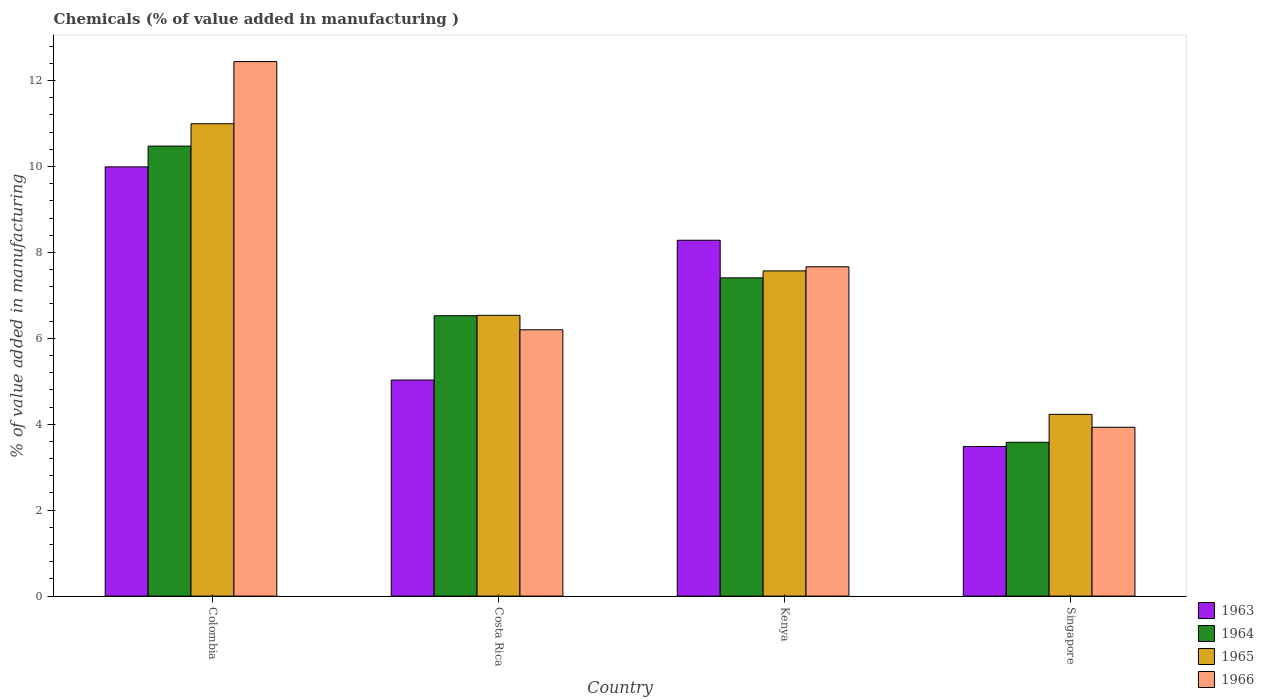How many different coloured bars are there?
Your response must be concise. 4. Are the number of bars on each tick of the X-axis equal?
Your response must be concise. Yes. What is the label of the 4th group of bars from the left?
Make the answer very short. Singapore. What is the value added in manufacturing chemicals in 1964 in Costa Rica?
Provide a succinct answer. 6.53. Across all countries, what is the maximum value added in manufacturing chemicals in 1964?
Offer a terse response. 10.47. Across all countries, what is the minimum value added in manufacturing chemicals in 1964?
Make the answer very short. 3.58. In which country was the value added in manufacturing chemicals in 1964 minimum?
Keep it short and to the point. Singapore. What is the total value added in manufacturing chemicals in 1963 in the graph?
Your response must be concise. 26.79. What is the difference between the value added in manufacturing chemicals in 1964 in Costa Rica and that in Singapore?
Make the answer very short. 2.95. What is the difference between the value added in manufacturing chemicals in 1966 in Kenya and the value added in manufacturing chemicals in 1965 in Colombia?
Give a very brief answer. -3.33. What is the average value added in manufacturing chemicals in 1963 per country?
Your answer should be compact. 6.7. What is the difference between the value added in manufacturing chemicals of/in 1963 and value added in manufacturing chemicals of/in 1964 in Singapore?
Make the answer very short. -0.1. In how many countries, is the value added in manufacturing chemicals in 1963 greater than 2.8 %?
Your response must be concise. 4. What is the ratio of the value added in manufacturing chemicals in 1963 in Colombia to that in Kenya?
Your answer should be compact. 1.21. What is the difference between the highest and the second highest value added in manufacturing chemicals in 1964?
Provide a short and direct response. 3.95. What is the difference between the highest and the lowest value added in manufacturing chemicals in 1963?
Ensure brevity in your answer.  6.51. In how many countries, is the value added in manufacturing chemicals in 1963 greater than the average value added in manufacturing chemicals in 1963 taken over all countries?
Provide a succinct answer. 2. Is the sum of the value added in manufacturing chemicals in 1965 in Kenya and Singapore greater than the maximum value added in manufacturing chemicals in 1966 across all countries?
Make the answer very short. No. What does the 2nd bar from the left in Kenya represents?
Your answer should be very brief. 1964. What does the 2nd bar from the right in Kenya represents?
Provide a short and direct response. 1965. Is it the case that in every country, the sum of the value added in manufacturing chemicals in 1964 and value added in manufacturing chemicals in 1966 is greater than the value added in manufacturing chemicals in 1963?
Your answer should be compact. Yes. Are all the bars in the graph horizontal?
Make the answer very short. No. How many countries are there in the graph?
Offer a terse response. 4. What is the difference between two consecutive major ticks on the Y-axis?
Provide a short and direct response. 2. Does the graph contain any zero values?
Provide a succinct answer. No. Where does the legend appear in the graph?
Give a very brief answer. Bottom right. How many legend labels are there?
Provide a short and direct response. 4. How are the legend labels stacked?
Provide a short and direct response. Vertical. What is the title of the graph?
Provide a succinct answer. Chemicals (% of value added in manufacturing ). What is the label or title of the X-axis?
Keep it short and to the point. Country. What is the label or title of the Y-axis?
Provide a short and direct response. % of value added in manufacturing. What is the % of value added in manufacturing of 1963 in Colombia?
Offer a terse response. 9.99. What is the % of value added in manufacturing of 1964 in Colombia?
Your answer should be very brief. 10.47. What is the % of value added in manufacturing of 1965 in Colombia?
Make the answer very short. 10.99. What is the % of value added in manufacturing of 1966 in Colombia?
Your answer should be very brief. 12.44. What is the % of value added in manufacturing in 1963 in Costa Rica?
Your response must be concise. 5.03. What is the % of value added in manufacturing in 1964 in Costa Rica?
Keep it short and to the point. 6.53. What is the % of value added in manufacturing of 1965 in Costa Rica?
Make the answer very short. 6.54. What is the % of value added in manufacturing in 1966 in Costa Rica?
Make the answer very short. 6.2. What is the % of value added in manufacturing of 1963 in Kenya?
Offer a very short reply. 8.28. What is the % of value added in manufacturing of 1964 in Kenya?
Give a very brief answer. 7.41. What is the % of value added in manufacturing in 1965 in Kenya?
Your answer should be very brief. 7.57. What is the % of value added in manufacturing in 1966 in Kenya?
Ensure brevity in your answer.  7.67. What is the % of value added in manufacturing in 1963 in Singapore?
Your answer should be compact. 3.48. What is the % of value added in manufacturing of 1964 in Singapore?
Provide a succinct answer. 3.58. What is the % of value added in manufacturing of 1965 in Singapore?
Offer a very short reply. 4.23. What is the % of value added in manufacturing in 1966 in Singapore?
Provide a succinct answer. 3.93. Across all countries, what is the maximum % of value added in manufacturing of 1963?
Give a very brief answer. 9.99. Across all countries, what is the maximum % of value added in manufacturing in 1964?
Give a very brief answer. 10.47. Across all countries, what is the maximum % of value added in manufacturing of 1965?
Your answer should be compact. 10.99. Across all countries, what is the maximum % of value added in manufacturing in 1966?
Ensure brevity in your answer.  12.44. Across all countries, what is the minimum % of value added in manufacturing of 1963?
Give a very brief answer. 3.48. Across all countries, what is the minimum % of value added in manufacturing of 1964?
Make the answer very short. 3.58. Across all countries, what is the minimum % of value added in manufacturing in 1965?
Ensure brevity in your answer.  4.23. Across all countries, what is the minimum % of value added in manufacturing of 1966?
Keep it short and to the point. 3.93. What is the total % of value added in manufacturing of 1963 in the graph?
Your response must be concise. 26.79. What is the total % of value added in manufacturing in 1964 in the graph?
Offer a very short reply. 27.99. What is the total % of value added in manufacturing of 1965 in the graph?
Provide a short and direct response. 29.33. What is the total % of value added in manufacturing of 1966 in the graph?
Your response must be concise. 30.23. What is the difference between the % of value added in manufacturing in 1963 in Colombia and that in Costa Rica?
Give a very brief answer. 4.96. What is the difference between the % of value added in manufacturing in 1964 in Colombia and that in Costa Rica?
Offer a terse response. 3.95. What is the difference between the % of value added in manufacturing of 1965 in Colombia and that in Costa Rica?
Provide a succinct answer. 4.46. What is the difference between the % of value added in manufacturing of 1966 in Colombia and that in Costa Rica?
Your answer should be very brief. 6.24. What is the difference between the % of value added in manufacturing of 1963 in Colombia and that in Kenya?
Give a very brief answer. 1.71. What is the difference between the % of value added in manufacturing of 1964 in Colombia and that in Kenya?
Your response must be concise. 3.07. What is the difference between the % of value added in manufacturing of 1965 in Colombia and that in Kenya?
Your response must be concise. 3.43. What is the difference between the % of value added in manufacturing of 1966 in Colombia and that in Kenya?
Your answer should be compact. 4.78. What is the difference between the % of value added in manufacturing in 1963 in Colombia and that in Singapore?
Your answer should be compact. 6.51. What is the difference between the % of value added in manufacturing in 1964 in Colombia and that in Singapore?
Your response must be concise. 6.89. What is the difference between the % of value added in manufacturing of 1965 in Colombia and that in Singapore?
Your answer should be very brief. 6.76. What is the difference between the % of value added in manufacturing of 1966 in Colombia and that in Singapore?
Ensure brevity in your answer.  8.51. What is the difference between the % of value added in manufacturing of 1963 in Costa Rica and that in Kenya?
Ensure brevity in your answer.  -3.25. What is the difference between the % of value added in manufacturing of 1964 in Costa Rica and that in Kenya?
Keep it short and to the point. -0.88. What is the difference between the % of value added in manufacturing in 1965 in Costa Rica and that in Kenya?
Your answer should be very brief. -1.03. What is the difference between the % of value added in manufacturing of 1966 in Costa Rica and that in Kenya?
Ensure brevity in your answer.  -1.47. What is the difference between the % of value added in manufacturing of 1963 in Costa Rica and that in Singapore?
Your response must be concise. 1.55. What is the difference between the % of value added in manufacturing of 1964 in Costa Rica and that in Singapore?
Your response must be concise. 2.95. What is the difference between the % of value added in manufacturing of 1965 in Costa Rica and that in Singapore?
Provide a succinct answer. 2.31. What is the difference between the % of value added in manufacturing of 1966 in Costa Rica and that in Singapore?
Your answer should be compact. 2.27. What is the difference between the % of value added in manufacturing in 1963 in Kenya and that in Singapore?
Offer a terse response. 4.8. What is the difference between the % of value added in manufacturing in 1964 in Kenya and that in Singapore?
Offer a very short reply. 3.83. What is the difference between the % of value added in manufacturing of 1965 in Kenya and that in Singapore?
Make the answer very short. 3.34. What is the difference between the % of value added in manufacturing in 1966 in Kenya and that in Singapore?
Provide a succinct answer. 3.74. What is the difference between the % of value added in manufacturing in 1963 in Colombia and the % of value added in manufacturing in 1964 in Costa Rica?
Your response must be concise. 3.47. What is the difference between the % of value added in manufacturing in 1963 in Colombia and the % of value added in manufacturing in 1965 in Costa Rica?
Offer a very short reply. 3.46. What is the difference between the % of value added in manufacturing of 1963 in Colombia and the % of value added in manufacturing of 1966 in Costa Rica?
Offer a very short reply. 3.79. What is the difference between the % of value added in manufacturing in 1964 in Colombia and the % of value added in manufacturing in 1965 in Costa Rica?
Provide a short and direct response. 3.94. What is the difference between the % of value added in manufacturing in 1964 in Colombia and the % of value added in manufacturing in 1966 in Costa Rica?
Ensure brevity in your answer.  4.28. What is the difference between the % of value added in manufacturing of 1965 in Colombia and the % of value added in manufacturing of 1966 in Costa Rica?
Provide a short and direct response. 4.8. What is the difference between the % of value added in manufacturing in 1963 in Colombia and the % of value added in manufacturing in 1964 in Kenya?
Keep it short and to the point. 2.58. What is the difference between the % of value added in manufacturing of 1963 in Colombia and the % of value added in manufacturing of 1965 in Kenya?
Your answer should be compact. 2.42. What is the difference between the % of value added in manufacturing of 1963 in Colombia and the % of value added in manufacturing of 1966 in Kenya?
Ensure brevity in your answer.  2.33. What is the difference between the % of value added in manufacturing of 1964 in Colombia and the % of value added in manufacturing of 1965 in Kenya?
Ensure brevity in your answer.  2.9. What is the difference between the % of value added in manufacturing in 1964 in Colombia and the % of value added in manufacturing in 1966 in Kenya?
Provide a succinct answer. 2.81. What is the difference between the % of value added in manufacturing of 1965 in Colombia and the % of value added in manufacturing of 1966 in Kenya?
Give a very brief answer. 3.33. What is the difference between the % of value added in manufacturing in 1963 in Colombia and the % of value added in manufacturing in 1964 in Singapore?
Provide a short and direct response. 6.41. What is the difference between the % of value added in manufacturing of 1963 in Colombia and the % of value added in manufacturing of 1965 in Singapore?
Offer a terse response. 5.76. What is the difference between the % of value added in manufacturing in 1963 in Colombia and the % of value added in manufacturing in 1966 in Singapore?
Your answer should be compact. 6.06. What is the difference between the % of value added in manufacturing of 1964 in Colombia and the % of value added in manufacturing of 1965 in Singapore?
Keep it short and to the point. 6.24. What is the difference between the % of value added in manufacturing in 1964 in Colombia and the % of value added in manufacturing in 1966 in Singapore?
Make the answer very short. 6.54. What is the difference between the % of value added in manufacturing of 1965 in Colombia and the % of value added in manufacturing of 1966 in Singapore?
Keep it short and to the point. 7.07. What is the difference between the % of value added in manufacturing in 1963 in Costa Rica and the % of value added in manufacturing in 1964 in Kenya?
Give a very brief answer. -2.38. What is the difference between the % of value added in manufacturing in 1963 in Costa Rica and the % of value added in manufacturing in 1965 in Kenya?
Ensure brevity in your answer.  -2.54. What is the difference between the % of value added in manufacturing of 1963 in Costa Rica and the % of value added in manufacturing of 1966 in Kenya?
Make the answer very short. -2.64. What is the difference between the % of value added in manufacturing of 1964 in Costa Rica and the % of value added in manufacturing of 1965 in Kenya?
Offer a terse response. -1.04. What is the difference between the % of value added in manufacturing in 1964 in Costa Rica and the % of value added in manufacturing in 1966 in Kenya?
Offer a terse response. -1.14. What is the difference between the % of value added in manufacturing of 1965 in Costa Rica and the % of value added in manufacturing of 1966 in Kenya?
Provide a short and direct response. -1.13. What is the difference between the % of value added in manufacturing of 1963 in Costa Rica and the % of value added in manufacturing of 1964 in Singapore?
Give a very brief answer. 1.45. What is the difference between the % of value added in manufacturing in 1963 in Costa Rica and the % of value added in manufacturing in 1965 in Singapore?
Ensure brevity in your answer.  0.8. What is the difference between the % of value added in manufacturing of 1963 in Costa Rica and the % of value added in manufacturing of 1966 in Singapore?
Offer a terse response. 1.1. What is the difference between the % of value added in manufacturing of 1964 in Costa Rica and the % of value added in manufacturing of 1965 in Singapore?
Keep it short and to the point. 2.3. What is the difference between the % of value added in manufacturing of 1964 in Costa Rica and the % of value added in manufacturing of 1966 in Singapore?
Your answer should be compact. 2.6. What is the difference between the % of value added in manufacturing of 1965 in Costa Rica and the % of value added in manufacturing of 1966 in Singapore?
Provide a short and direct response. 2.61. What is the difference between the % of value added in manufacturing of 1963 in Kenya and the % of value added in manufacturing of 1964 in Singapore?
Your answer should be compact. 4.7. What is the difference between the % of value added in manufacturing in 1963 in Kenya and the % of value added in manufacturing in 1965 in Singapore?
Ensure brevity in your answer.  4.05. What is the difference between the % of value added in manufacturing in 1963 in Kenya and the % of value added in manufacturing in 1966 in Singapore?
Your response must be concise. 4.35. What is the difference between the % of value added in manufacturing in 1964 in Kenya and the % of value added in manufacturing in 1965 in Singapore?
Offer a very short reply. 3.18. What is the difference between the % of value added in manufacturing of 1964 in Kenya and the % of value added in manufacturing of 1966 in Singapore?
Your answer should be compact. 3.48. What is the difference between the % of value added in manufacturing of 1965 in Kenya and the % of value added in manufacturing of 1966 in Singapore?
Your response must be concise. 3.64. What is the average % of value added in manufacturing of 1963 per country?
Make the answer very short. 6.7. What is the average % of value added in manufacturing of 1964 per country?
Your answer should be very brief. 7. What is the average % of value added in manufacturing in 1965 per country?
Offer a very short reply. 7.33. What is the average % of value added in manufacturing of 1966 per country?
Your response must be concise. 7.56. What is the difference between the % of value added in manufacturing of 1963 and % of value added in manufacturing of 1964 in Colombia?
Offer a terse response. -0.48. What is the difference between the % of value added in manufacturing of 1963 and % of value added in manufacturing of 1965 in Colombia?
Offer a terse response. -1. What is the difference between the % of value added in manufacturing in 1963 and % of value added in manufacturing in 1966 in Colombia?
Ensure brevity in your answer.  -2.45. What is the difference between the % of value added in manufacturing in 1964 and % of value added in manufacturing in 1965 in Colombia?
Give a very brief answer. -0.52. What is the difference between the % of value added in manufacturing in 1964 and % of value added in manufacturing in 1966 in Colombia?
Keep it short and to the point. -1.97. What is the difference between the % of value added in manufacturing in 1965 and % of value added in manufacturing in 1966 in Colombia?
Give a very brief answer. -1.45. What is the difference between the % of value added in manufacturing of 1963 and % of value added in manufacturing of 1964 in Costa Rica?
Offer a terse response. -1.5. What is the difference between the % of value added in manufacturing in 1963 and % of value added in manufacturing in 1965 in Costa Rica?
Your answer should be very brief. -1.51. What is the difference between the % of value added in manufacturing in 1963 and % of value added in manufacturing in 1966 in Costa Rica?
Your answer should be compact. -1.17. What is the difference between the % of value added in manufacturing in 1964 and % of value added in manufacturing in 1965 in Costa Rica?
Provide a succinct answer. -0.01. What is the difference between the % of value added in manufacturing of 1964 and % of value added in manufacturing of 1966 in Costa Rica?
Your answer should be compact. 0.33. What is the difference between the % of value added in manufacturing in 1965 and % of value added in manufacturing in 1966 in Costa Rica?
Offer a very short reply. 0.34. What is the difference between the % of value added in manufacturing of 1963 and % of value added in manufacturing of 1964 in Kenya?
Keep it short and to the point. 0.87. What is the difference between the % of value added in manufacturing of 1963 and % of value added in manufacturing of 1965 in Kenya?
Give a very brief answer. 0.71. What is the difference between the % of value added in manufacturing in 1963 and % of value added in manufacturing in 1966 in Kenya?
Make the answer very short. 0.62. What is the difference between the % of value added in manufacturing of 1964 and % of value added in manufacturing of 1965 in Kenya?
Your response must be concise. -0.16. What is the difference between the % of value added in manufacturing in 1964 and % of value added in manufacturing in 1966 in Kenya?
Keep it short and to the point. -0.26. What is the difference between the % of value added in manufacturing in 1965 and % of value added in manufacturing in 1966 in Kenya?
Make the answer very short. -0.1. What is the difference between the % of value added in manufacturing in 1963 and % of value added in manufacturing in 1964 in Singapore?
Make the answer very short. -0.1. What is the difference between the % of value added in manufacturing in 1963 and % of value added in manufacturing in 1965 in Singapore?
Offer a terse response. -0.75. What is the difference between the % of value added in manufacturing in 1963 and % of value added in manufacturing in 1966 in Singapore?
Ensure brevity in your answer.  -0.45. What is the difference between the % of value added in manufacturing of 1964 and % of value added in manufacturing of 1965 in Singapore?
Offer a terse response. -0.65. What is the difference between the % of value added in manufacturing of 1964 and % of value added in manufacturing of 1966 in Singapore?
Provide a succinct answer. -0.35. What is the difference between the % of value added in manufacturing of 1965 and % of value added in manufacturing of 1966 in Singapore?
Keep it short and to the point. 0.3. What is the ratio of the % of value added in manufacturing in 1963 in Colombia to that in Costa Rica?
Give a very brief answer. 1.99. What is the ratio of the % of value added in manufacturing of 1964 in Colombia to that in Costa Rica?
Provide a short and direct response. 1.61. What is the ratio of the % of value added in manufacturing in 1965 in Colombia to that in Costa Rica?
Offer a terse response. 1.68. What is the ratio of the % of value added in manufacturing in 1966 in Colombia to that in Costa Rica?
Provide a succinct answer. 2.01. What is the ratio of the % of value added in manufacturing in 1963 in Colombia to that in Kenya?
Make the answer very short. 1.21. What is the ratio of the % of value added in manufacturing in 1964 in Colombia to that in Kenya?
Make the answer very short. 1.41. What is the ratio of the % of value added in manufacturing of 1965 in Colombia to that in Kenya?
Offer a very short reply. 1.45. What is the ratio of the % of value added in manufacturing of 1966 in Colombia to that in Kenya?
Keep it short and to the point. 1.62. What is the ratio of the % of value added in manufacturing in 1963 in Colombia to that in Singapore?
Offer a very short reply. 2.87. What is the ratio of the % of value added in manufacturing in 1964 in Colombia to that in Singapore?
Provide a succinct answer. 2.93. What is the ratio of the % of value added in manufacturing in 1965 in Colombia to that in Singapore?
Ensure brevity in your answer.  2.6. What is the ratio of the % of value added in manufacturing in 1966 in Colombia to that in Singapore?
Your response must be concise. 3.17. What is the ratio of the % of value added in manufacturing of 1963 in Costa Rica to that in Kenya?
Offer a terse response. 0.61. What is the ratio of the % of value added in manufacturing in 1964 in Costa Rica to that in Kenya?
Keep it short and to the point. 0.88. What is the ratio of the % of value added in manufacturing in 1965 in Costa Rica to that in Kenya?
Keep it short and to the point. 0.86. What is the ratio of the % of value added in manufacturing in 1966 in Costa Rica to that in Kenya?
Your answer should be compact. 0.81. What is the ratio of the % of value added in manufacturing in 1963 in Costa Rica to that in Singapore?
Offer a terse response. 1.44. What is the ratio of the % of value added in manufacturing in 1964 in Costa Rica to that in Singapore?
Make the answer very short. 1.82. What is the ratio of the % of value added in manufacturing in 1965 in Costa Rica to that in Singapore?
Keep it short and to the point. 1.55. What is the ratio of the % of value added in manufacturing of 1966 in Costa Rica to that in Singapore?
Keep it short and to the point. 1.58. What is the ratio of the % of value added in manufacturing in 1963 in Kenya to that in Singapore?
Keep it short and to the point. 2.38. What is the ratio of the % of value added in manufacturing of 1964 in Kenya to that in Singapore?
Ensure brevity in your answer.  2.07. What is the ratio of the % of value added in manufacturing of 1965 in Kenya to that in Singapore?
Your response must be concise. 1.79. What is the ratio of the % of value added in manufacturing in 1966 in Kenya to that in Singapore?
Offer a terse response. 1.95. What is the difference between the highest and the second highest % of value added in manufacturing in 1963?
Offer a very short reply. 1.71. What is the difference between the highest and the second highest % of value added in manufacturing in 1964?
Keep it short and to the point. 3.07. What is the difference between the highest and the second highest % of value added in manufacturing of 1965?
Provide a short and direct response. 3.43. What is the difference between the highest and the second highest % of value added in manufacturing in 1966?
Your response must be concise. 4.78. What is the difference between the highest and the lowest % of value added in manufacturing in 1963?
Your answer should be very brief. 6.51. What is the difference between the highest and the lowest % of value added in manufacturing in 1964?
Provide a succinct answer. 6.89. What is the difference between the highest and the lowest % of value added in manufacturing in 1965?
Offer a terse response. 6.76. What is the difference between the highest and the lowest % of value added in manufacturing of 1966?
Offer a terse response. 8.51. 